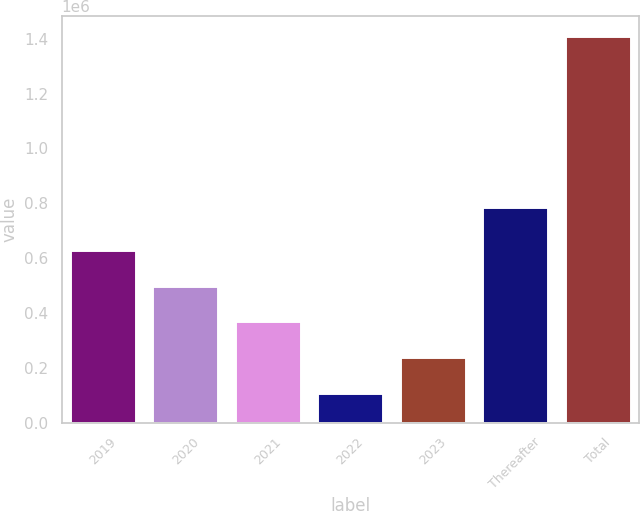Convert chart. <chart><loc_0><loc_0><loc_500><loc_500><bar_chart><fcel>2019<fcel>2020<fcel>2021<fcel>2022<fcel>2023<fcel>Thereafter<fcel>Total<nl><fcel>629965<fcel>499744<fcel>369524<fcel>109083<fcel>239303<fcel>784817<fcel>1.41129e+06<nl></chart> 